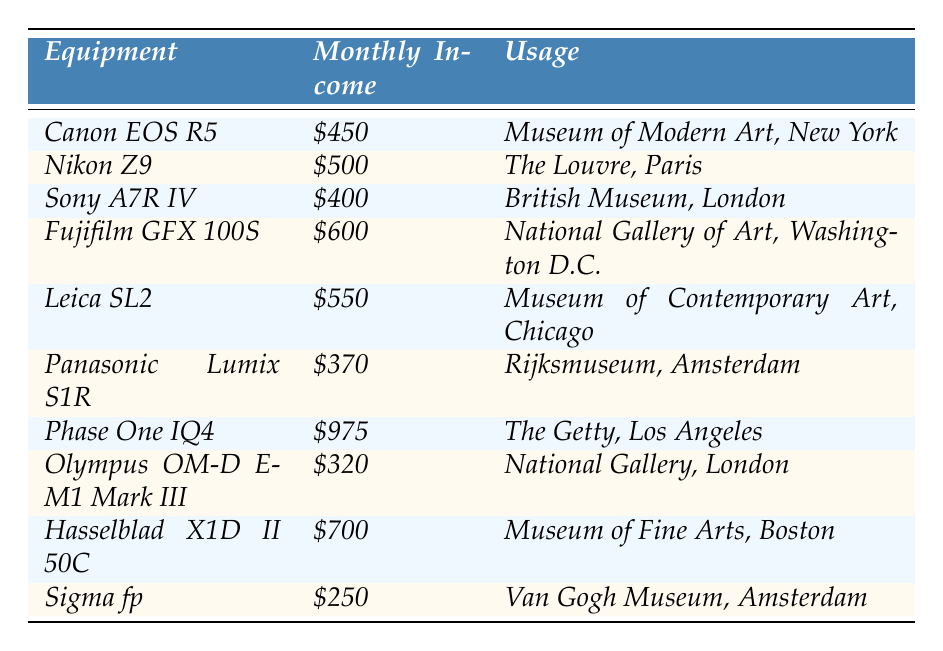What is the highest monthly rental income for photography equipment? The table lists the monthly rental incomes for various equipment, and the highest value found is $975 for the Phase One IQ4.
Answer: $975 Which museum is renting the Nikon Z9? According to the table, the Nikon Z9 is rented by The Louvre in Paris.
Answer: The Louvre, Paris What is the total monthly rental income from all pieces of equipment listed? Summing all the monthly incomes: $450 + $500 + $400 + $600 + $550 + $370 + $975 + $320 + $700 + $250 = $4,115.
Answer: $4,115 Is the monthly rental income for the Olympus OM-D E-M1 Mark III greater than $300? The table shows that the monthly rental income for the Olympus OM-D E-M1 Mark III is $320, which is greater than $300.
Answer: Yes What is the average monthly rental income from the equipment listed? First, calculate the total monthly income, which is $4,115, and then divide by the number of equipment items, which is 10: $4,115 / 10 = $411.50.
Answer: $411.50 Which equipment generates more income, the Canon EOS R5 or the Sony A7R IV? The Canon EOS R5 has an income of $450, while the Sony A7R IV has an income of $400. Since $450 is greater than $400, the Canon EOS R5 generates more income.
Answer: Canon EOS R5 How many pieces of equipment have a monthly rental income over $500? The table lists the pieces of equipment and their incomes; those over $500 are the Nikon Z9 ($500), Fujifilm GFX 100S ($600), Leica SL2 ($550), and Phase One IQ4 ($975), totaling 4 items.
Answer: 4 What is the usage location for the Hasselblad X1D II 50C? The table states that the Hasselblad X1D II 50C is used at the Museum of Fine Arts in Boston.
Answer: Museum of Fine Arts, Boston If I combine the income from the Leica SL2 and the Panasonic Lumix S1R, what is the total? The Leica SL2 income is $550, and the Panasonic Lumix S1R is $370. Adding these gives $550 + $370 = $920.
Answer: $920 Is there any equipment with a rental income less than $300? Looking at the table, the Sigma fp has a rental income of $250, which is less than $300.
Answer: Yes Which equipment has the second-highest monthly rental income? By examining the incomes in descending order, the Phase One IQ4 is the highest ($975), and the second highest is the Hasselblad X1D II 50C at $700.
Answer: Hasselblad X1D II 50C 